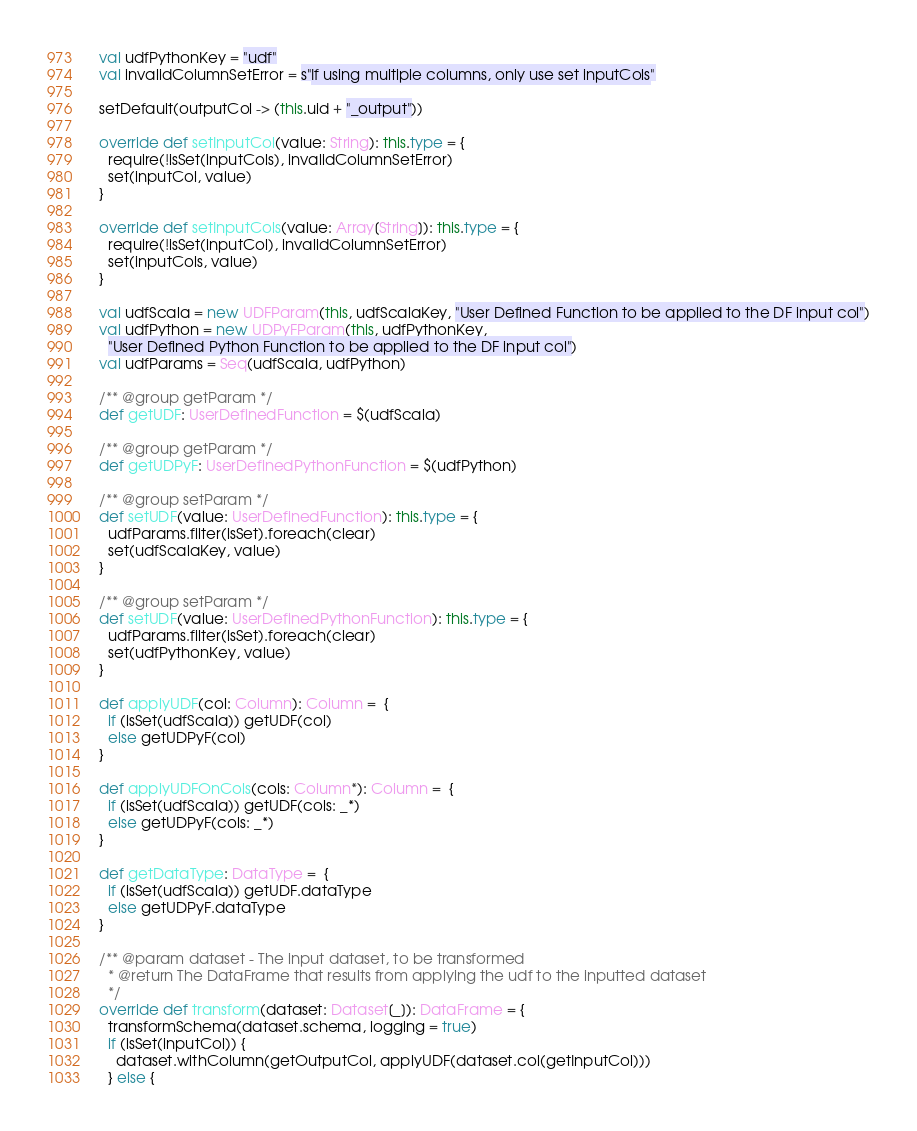<code> <loc_0><loc_0><loc_500><loc_500><_Scala_>  val udfPythonKey = "udf"
  val invalidColumnSetError = s"If using multiple columns, only use set inputCols"

  setDefault(outputCol -> (this.uid + "_output"))

  override def setInputCol(value: String): this.type = {
    require(!isSet(inputCols), invalidColumnSetError)
    set(inputCol, value)
  }

  override def setInputCols(value: Array[String]): this.type = {
    require(!isSet(inputCol), invalidColumnSetError)
    set(inputCols, value)
  }

  val udfScala = new UDFParam(this, udfScalaKey, "User Defined Function to be applied to the DF input col")
  val udfPython = new UDPyFParam(this, udfPythonKey,
    "User Defined Python Function to be applied to the DF input col")
  val udfParams = Seq(udfScala, udfPython)

  /** @group getParam */
  def getUDF: UserDefinedFunction = $(udfScala)

  /** @group getParam */
  def getUDPyF: UserDefinedPythonFunction = $(udfPython)

  /** @group setParam */
  def setUDF(value: UserDefinedFunction): this.type = {
    udfParams.filter(isSet).foreach(clear)
    set(udfScalaKey, value)
  }

  /** @group setParam */
  def setUDF(value: UserDefinedPythonFunction): this.type = {
    udfParams.filter(isSet).foreach(clear)
    set(udfPythonKey, value)
  }

  def applyUDF(col: Column): Column =  {
    if (isSet(udfScala)) getUDF(col)
    else getUDPyF(col)
  }

  def applyUDFOnCols(cols: Column*): Column =  {
    if (isSet(udfScala)) getUDF(cols: _*)
    else getUDPyF(cols: _*)
  }

  def getDataType: DataType =  {
    if (isSet(udfScala)) getUDF.dataType
    else getUDPyF.dataType
  }

  /** @param dataset - The input dataset, to be transformed
    * @return The DataFrame that results from applying the udf to the inputted dataset
    */
  override def transform(dataset: Dataset[_]): DataFrame = {
    transformSchema(dataset.schema, logging = true)
    if (isSet(inputCol)) {
      dataset.withColumn(getOutputCol, applyUDF(dataset.col(getInputCol)))
    } else {</code> 